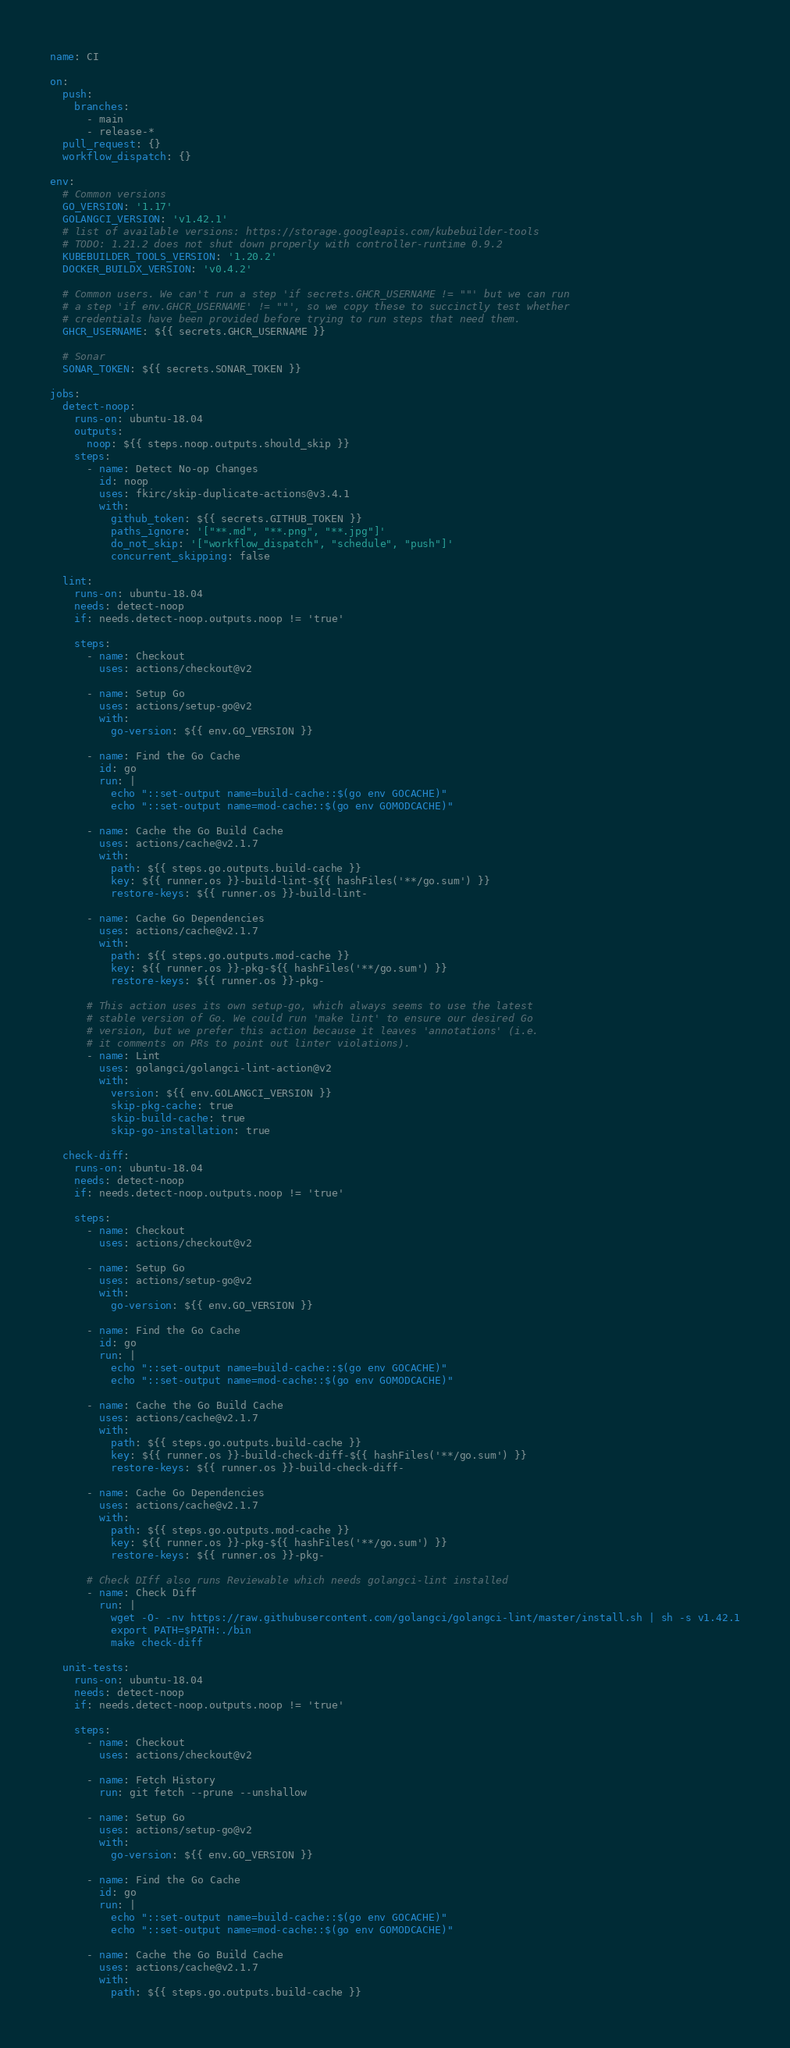Convert code to text. <code><loc_0><loc_0><loc_500><loc_500><_YAML_>name: CI

on:
  push:
    branches:
      - main
      - release-*
  pull_request: {}
  workflow_dispatch: {}

env:
  # Common versions
  GO_VERSION: '1.17'
  GOLANGCI_VERSION: 'v1.42.1'
  # list of available versions: https://storage.googleapis.com/kubebuilder-tools
  # TODO: 1.21.2 does not shut down properly with controller-runtime 0.9.2
  KUBEBUILDER_TOOLS_VERSION: '1.20.2'
  DOCKER_BUILDX_VERSION: 'v0.4.2'

  # Common users. We can't run a step 'if secrets.GHCR_USERNAME != ""' but we can run
  # a step 'if env.GHCR_USERNAME' != ""', so we copy these to succinctly test whether
  # credentials have been provided before trying to run steps that need them.
  GHCR_USERNAME: ${{ secrets.GHCR_USERNAME }}

  # Sonar
  SONAR_TOKEN: ${{ secrets.SONAR_TOKEN }}

jobs:
  detect-noop:
    runs-on: ubuntu-18.04
    outputs:
      noop: ${{ steps.noop.outputs.should_skip }}
    steps:
      - name: Detect No-op Changes
        id: noop
        uses: fkirc/skip-duplicate-actions@v3.4.1
        with:
          github_token: ${{ secrets.GITHUB_TOKEN }}
          paths_ignore: '["**.md", "**.png", "**.jpg"]'
          do_not_skip: '["workflow_dispatch", "schedule", "push"]'
          concurrent_skipping: false

  lint:
    runs-on: ubuntu-18.04
    needs: detect-noop
    if: needs.detect-noop.outputs.noop != 'true'

    steps:
      - name: Checkout
        uses: actions/checkout@v2

      - name: Setup Go
        uses: actions/setup-go@v2
        with:
          go-version: ${{ env.GO_VERSION }}

      - name: Find the Go Cache
        id: go
        run: |
          echo "::set-output name=build-cache::$(go env GOCACHE)"
          echo "::set-output name=mod-cache::$(go env GOMODCACHE)"

      - name: Cache the Go Build Cache
        uses: actions/cache@v2.1.7
        with:
          path: ${{ steps.go.outputs.build-cache }}
          key: ${{ runner.os }}-build-lint-${{ hashFiles('**/go.sum') }}
          restore-keys: ${{ runner.os }}-build-lint-

      - name: Cache Go Dependencies
        uses: actions/cache@v2.1.7
        with:
          path: ${{ steps.go.outputs.mod-cache }}
          key: ${{ runner.os }}-pkg-${{ hashFiles('**/go.sum') }}
          restore-keys: ${{ runner.os }}-pkg-

      # This action uses its own setup-go, which always seems to use the latest
      # stable version of Go. We could run 'make lint' to ensure our desired Go
      # version, but we prefer this action because it leaves 'annotations' (i.e.
      # it comments on PRs to point out linter violations).
      - name: Lint
        uses: golangci/golangci-lint-action@v2
        with:
          version: ${{ env.GOLANGCI_VERSION }}
          skip-pkg-cache: true
          skip-build-cache: true
          skip-go-installation: true

  check-diff:
    runs-on: ubuntu-18.04
    needs: detect-noop
    if: needs.detect-noop.outputs.noop != 'true'

    steps:
      - name: Checkout
        uses: actions/checkout@v2

      - name: Setup Go
        uses: actions/setup-go@v2
        with:
          go-version: ${{ env.GO_VERSION }}

      - name: Find the Go Cache
        id: go
        run: |
          echo "::set-output name=build-cache::$(go env GOCACHE)"
          echo "::set-output name=mod-cache::$(go env GOMODCACHE)"

      - name: Cache the Go Build Cache
        uses: actions/cache@v2.1.7
        with:
          path: ${{ steps.go.outputs.build-cache }}
          key: ${{ runner.os }}-build-check-diff-${{ hashFiles('**/go.sum') }}
          restore-keys: ${{ runner.os }}-build-check-diff-

      - name: Cache Go Dependencies
        uses: actions/cache@v2.1.7
        with:
          path: ${{ steps.go.outputs.mod-cache }}
          key: ${{ runner.os }}-pkg-${{ hashFiles('**/go.sum') }}
          restore-keys: ${{ runner.os }}-pkg-

      # Check DIff also runs Reviewable which needs golangci-lint installed
      - name: Check Diff
        run: |
          wget -O- -nv https://raw.githubusercontent.com/golangci/golangci-lint/master/install.sh | sh -s v1.42.1
          export PATH=$PATH:./bin
          make check-diff

  unit-tests:
    runs-on: ubuntu-18.04
    needs: detect-noop
    if: needs.detect-noop.outputs.noop != 'true'

    steps:
      - name: Checkout
        uses: actions/checkout@v2

      - name: Fetch History
        run: git fetch --prune --unshallow

      - name: Setup Go
        uses: actions/setup-go@v2
        with:
          go-version: ${{ env.GO_VERSION }}

      - name: Find the Go Cache
        id: go
        run: |
          echo "::set-output name=build-cache::$(go env GOCACHE)"
          echo "::set-output name=mod-cache::$(go env GOMODCACHE)"

      - name: Cache the Go Build Cache
        uses: actions/cache@v2.1.7
        with:
          path: ${{ steps.go.outputs.build-cache }}</code> 